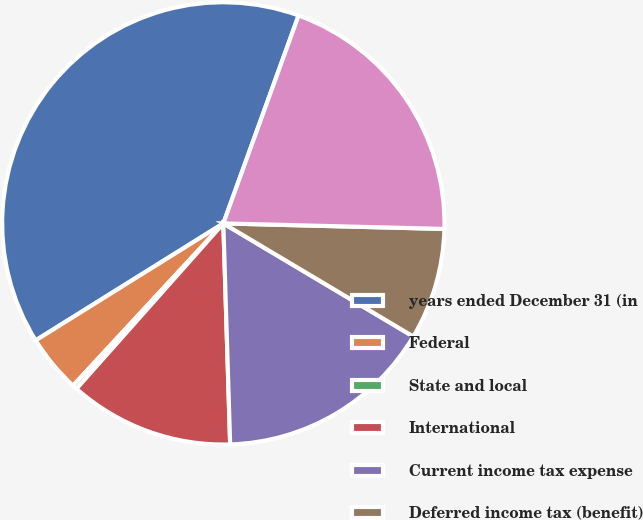Convert chart. <chart><loc_0><loc_0><loc_500><loc_500><pie_chart><fcel>years ended December 31 (in<fcel>Federal<fcel>State and local<fcel>International<fcel>Current income tax expense<fcel>Deferred income tax (benefit)<fcel>Income tax expense<nl><fcel>39.4%<fcel>4.24%<fcel>0.33%<fcel>12.05%<fcel>15.96%<fcel>8.15%<fcel>19.87%<nl></chart> 